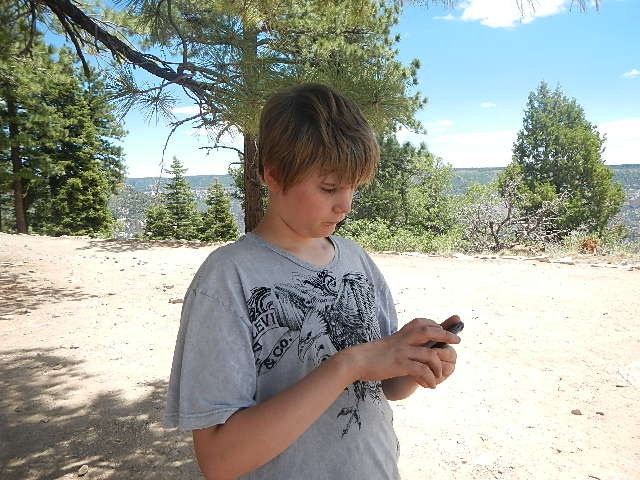Describe the objects in this image and their specific colors. I can see people in darkgreen, darkgray, brown, gray, and black tones and cell phone in darkgreen, black, gray, and darkgray tones in this image. 